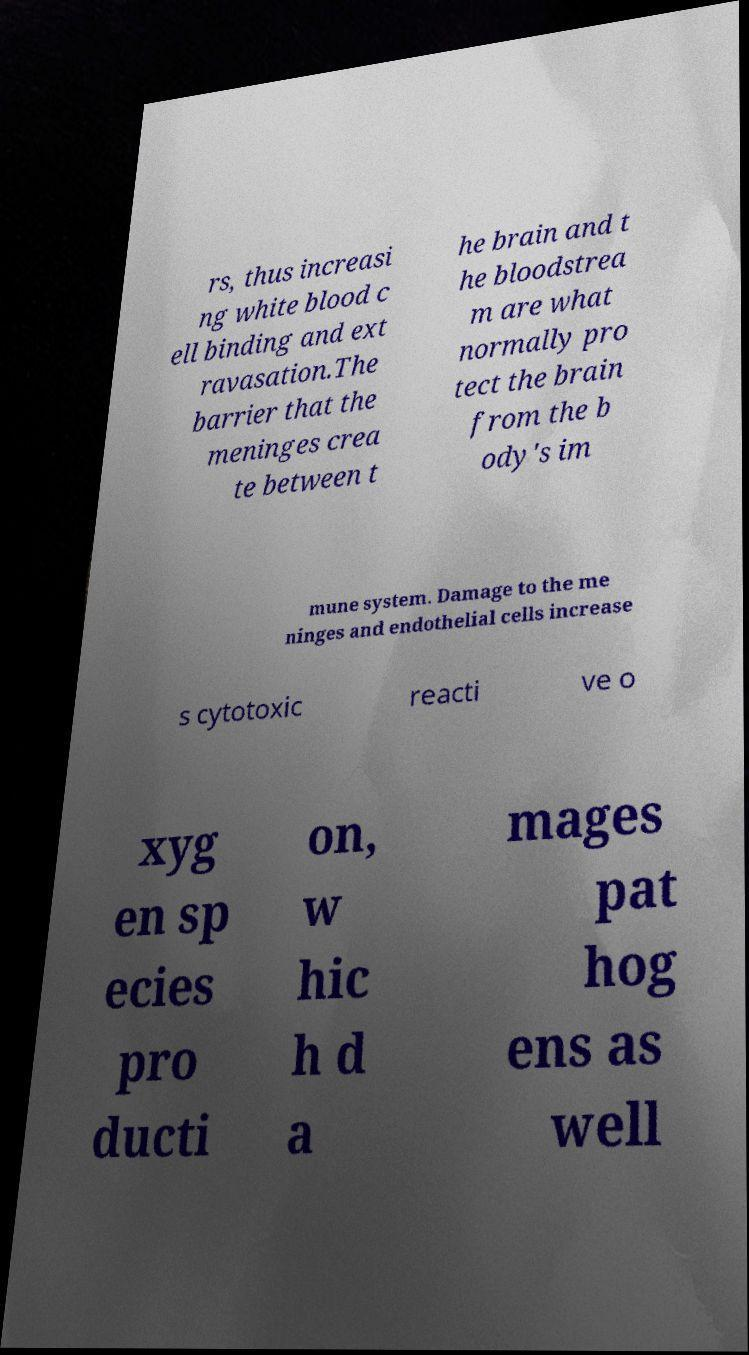Can you read and provide the text displayed in the image?This photo seems to have some interesting text. Can you extract and type it out for me? rs, thus increasi ng white blood c ell binding and ext ravasation.The barrier that the meninges crea te between t he brain and t he bloodstrea m are what normally pro tect the brain from the b ody's im mune system. Damage to the me ninges and endothelial cells increase s cytotoxic reacti ve o xyg en sp ecies pro ducti on, w hic h d a mages pat hog ens as well 